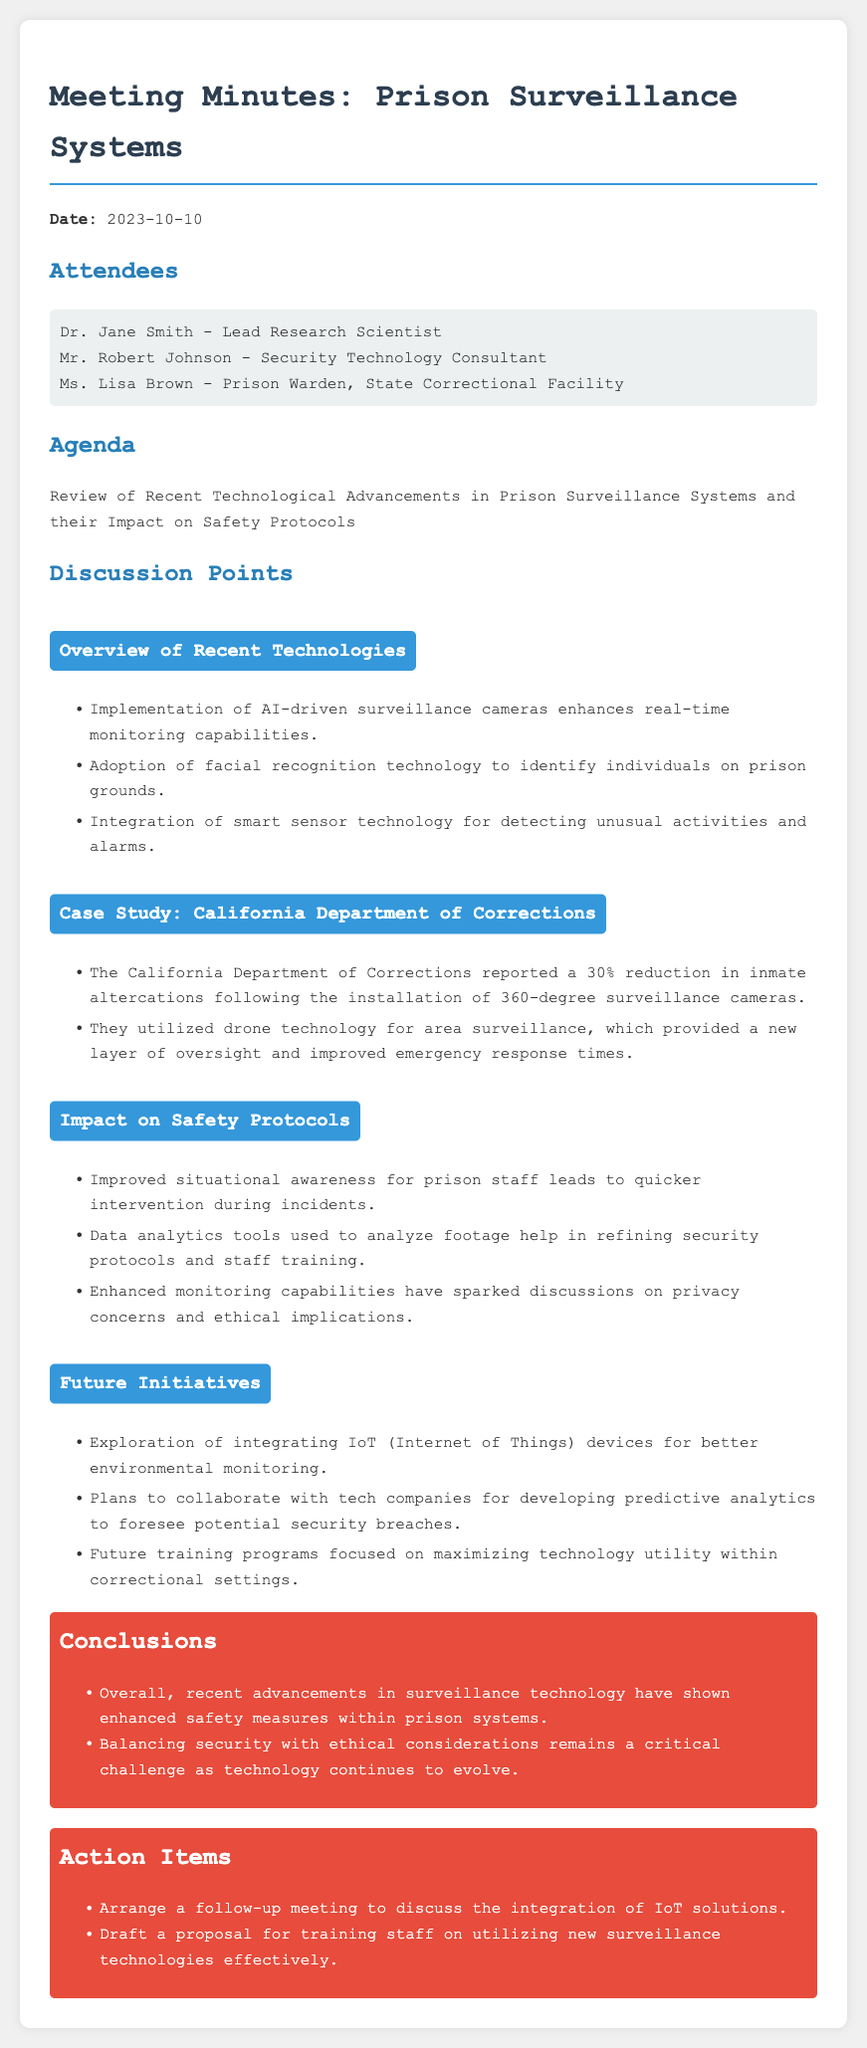What was the date of the meeting? The date of the meeting is mentioned at the beginning of the document.
Answer: 2023-10-10 Who is the Lead Research Scientist? The document lists attendees along with their roles, providing the name of the Lead Research Scientist.
Answer: Dr. Jane Smith What technology was adopted for identifying individuals? The document details recent technological advancements, including specific technologies used in prison surveillance systems.
Answer: Facial recognition technology What percentage reduction in inmate altercations did California report? The case study section contains quantitative data on the impact of surveillance systems in the California Department of Corrections.
Answer: 30% What major challenge does the document highlight regarding advancements in surveillance technology? The conclusions section discusses a significant challenge posed by technological advancements, specifically within the context of prison systems.
Answer: Balancing security with ethical considerations What future initiative involves environmental monitoring? Future initiatives listed in the document mention exploring a specific technology related to environmental monitoring.
Answer: Integrating IoT (Internet of Things) devices What impact does improved situational awareness have on prison staff? The document discusses the effects of recent technological advancements on safety protocols and responses.
Answer: Quicker intervention during incidents What should be discussed in the follow-up meeting? The action items section indicates key points for the next meeting, related to the integration of new solutions.
Answer: Integration of IoT solutions What is the purpose of the proposal that needs to be drafted? The action items indicate that there is a need for a specific proposal related to staff training.
Answer: Training staff on utilizing new surveillance technologies effectively 